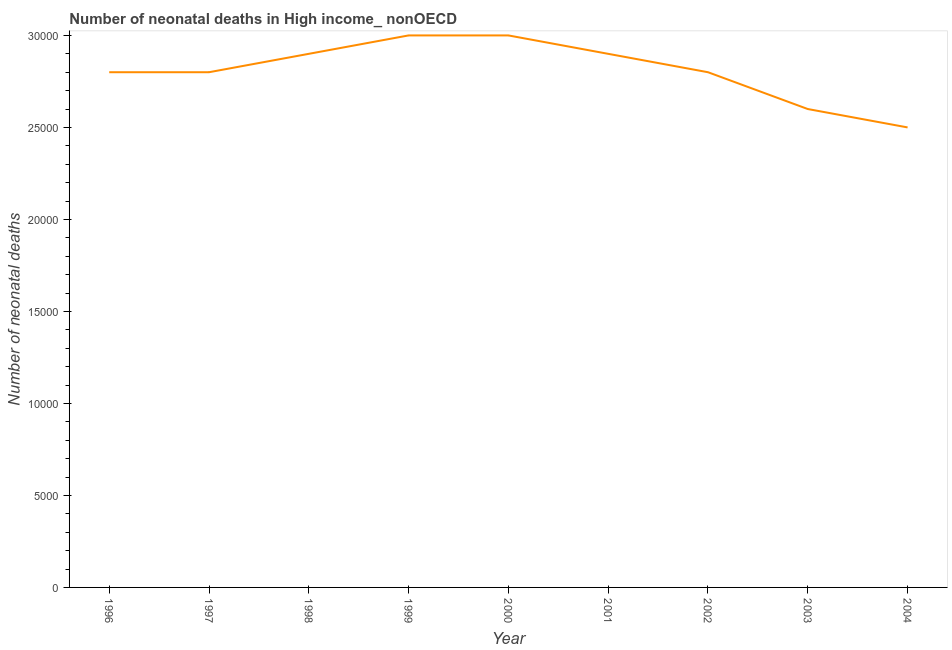What is the number of neonatal deaths in 1996?
Keep it short and to the point. 2.80e+04. Across all years, what is the maximum number of neonatal deaths?
Make the answer very short. 3.00e+04. Across all years, what is the minimum number of neonatal deaths?
Your answer should be very brief. 2.50e+04. What is the sum of the number of neonatal deaths?
Ensure brevity in your answer.  2.53e+05. What is the difference between the number of neonatal deaths in 1997 and 1998?
Provide a succinct answer. -1000. What is the average number of neonatal deaths per year?
Your answer should be compact. 2.81e+04. What is the median number of neonatal deaths?
Give a very brief answer. 2.80e+04. What is the ratio of the number of neonatal deaths in 1997 to that in 2003?
Your answer should be very brief. 1.08. What is the difference between the highest and the lowest number of neonatal deaths?
Your answer should be very brief. 5000. In how many years, is the number of neonatal deaths greater than the average number of neonatal deaths taken over all years?
Give a very brief answer. 4. Does the number of neonatal deaths monotonically increase over the years?
Give a very brief answer. No. How many years are there in the graph?
Offer a terse response. 9. Are the values on the major ticks of Y-axis written in scientific E-notation?
Your answer should be very brief. No. What is the title of the graph?
Provide a short and direct response. Number of neonatal deaths in High income_ nonOECD. What is the label or title of the X-axis?
Make the answer very short. Year. What is the label or title of the Y-axis?
Make the answer very short. Number of neonatal deaths. What is the Number of neonatal deaths in 1996?
Give a very brief answer. 2.80e+04. What is the Number of neonatal deaths of 1997?
Your answer should be compact. 2.80e+04. What is the Number of neonatal deaths of 1998?
Keep it short and to the point. 2.90e+04. What is the Number of neonatal deaths in 2000?
Offer a terse response. 3.00e+04. What is the Number of neonatal deaths in 2001?
Provide a succinct answer. 2.90e+04. What is the Number of neonatal deaths of 2002?
Make the answer very short. 2.80e+04. What is the Number of neonatal deaths of 2003?
Offer a terse response. 2.60e+04. What is the Number of neonatal deaths in 2004?
Your answer should be compact. 2.50e+04. What is the difference between the Number of neonatal deaths in 1996 and 1998?
Your response must be concise. -1000. What is the difference between the Number of neonatal deaths in 1996 and 1999?
Ensure brevity in your answer.  -2000. What is the difference between the Number of neonatal deaths in 1996 and 2000?
Your response must be concise. -2000. What is the difference between the Number of neonatal deaths in 1996 and 2001?
Provide a short and direct response. -1000. What is the difference between the Number of neonatal deaths in 1996 and 2004?
Your response must be concise. 3000. What is the difference between the Number of neonatal deaths in 1997 and 1998?
Offer a terse response. -1000. What is the difference between the Number of neonatal deaths in 1997 and 1999?
Offer a very short reply. -2000. What is the difference between the Number of neonatal deaths in 1997 and 2000?
Your answer should be compact. -2000. What is the difference between the Number of neonatal deaths in 1997 and 2001?
Your answer should be compact. -1000. What is the difference between the Number of neonatal deaths in 1997 and 2003?
Give a very brief answer. 2000. What is the difference between the Number of neonatal deaths in 1997 and 2004?
Provide a succinct answer. 3000. What is the difference between the Number of neonatal deaths in 1998 and 1999?
Offer a very short reply. -1000. What is the difference between the Number of neonatal deaths in 1998 and 2000?
Your answer should be very brief. -1000. What is the difference between the Number of neonatal deaths in 1998 and 2001?
Keep it short and to the point. 0. What is the difference between the Number of neonatal deaths in 1998 and 2003?
Your response must be concise. 3000. What is the difference between the Number of neonatal deaths in 1998 and 2004?
Provide a short and direct response. 4000. What is the difference between the Number of neonatal deaths in 1999 and 2001?
Make the answer very short. 1000. What is the difference between the Number of neonatal deaths in 1999 and 2003?
Give a very brief answer. 4000. What is the difference between the Number of neonatal deaths in 1999 and 2004?
Keep it short and to the point. 5000. What is the difference between the Number of neonatal deaths in 2000 and 2002?
Ensure brevity in your answer.  2000. What is the difference between the Number of neonatal deaths in 2000 and 2003?
Your response must be concise. 4000. What is the difference between the Number of neonatal deaths in 2000 and 2004?
Provide a succinct answer. 5000. What is the difference between the Number of neonatal deaths in 2001 and 2003?
Make the answer very short. 3000. What is the difference between the Number of neonatal deaths in 2001 and 2004?
Offer a very short reply. 4000. What is the difference between the Number of neonatal deaths in 2002 and 2003?
Make the answer very short. 2000. What is the difference between the Number of neonatal deaths in 2002 and 2004?
Offer a terse response. 3000. What is the ratio of the Number of neonatal deaths in 1996 to that in 1999?
Your answer should be very brief. 0.93. What is the ratio of the Number of neonatal deaths in 1996 to that in 2000?
Your answer should be very brief. 0.93. What is the ratio of the Number of neonatal deaths in 1996 to that in 2003?
Ensure brevity in your answer.  1.08. What is the ratio of the Number of neonatal deaths in 1996 to that in 2004?
Your answer should be very brief. 1.12. What is the ratio of the Number of neonatal deaths in 1997 to that in 1999?
Your answer should be compact. 0.93. What is the ratio of the Number of neonatal deaths in 1997 to that in 2000?
Ensure brevity in your answer.  0.93. What is the ratio of the Number of neonatal deaths in 1997 to that in 2002?
Your response must be concise. 1. What is the ratio of the Number of neonatal deaths in 1997 to that in 2003?
Ensure brevity in your answer.  1.08. What is the ratio of the Number of neonatal deaths in 1997 to that in 2004?
Offer a terse response. 1.12. What is the ratio of the Number of neonatal deaths in 1998 to that in 1999?
Your response must be concise. 0.97. What is the ratio of the Number of neonatal deaths in 1998 to that in 2001?
Your answer should be compact. 1. What is the ratio of the Number of neonatal deaths in 1998 to that in 2002?
Provide a short and direct response. 1.04. What is the ratio of the Number of neonatal deaths in 1998 to that in 2003?
Your answer should be compact. 1.11. What is the ratio of the Number of neonatal deaths in 1998 to that in 2004?
Provide a succinct answer. 1.16. What is the ratio of the Number of neonatal deaths in 1999 to that in 2000?
Your response must be concise. 1. What is the ratio of the Number of neonatal deaths in 1999 to that in 2001?
Your answer should be compact. 1.03. What is the ratio of the Number of neonatal deaths in 1999 to that in 2002?
Your response must be concise. 1.07. What is the ratio of the Number of neonatal deaths in 1999 to that in 2003?
Provide a short and direct response. 1.15. What is the ratio of the Number of neonatal deaths in 1999 to that in 2004?
Offer a terse response. 1.2. What is the ratio of the Number of neonatal deaths in 2000 to that in 2001?
Make the answer very short. 1.03. What is the ratio of the Number of neonatal deaths in 2000 to that in 2002?
Your answer should be very brief. 1.07. What is the ratio of the Number of neonatal deaths in 2000 to that in 2003?
Your answer should be compact. 1.15. What is the ratio of the Number of neonatal deaths in 2001 to that in 2002?
Offer a very short reply. 1.04. What is the ratio of the Number of neonatal deaths in 2001 to that in 2003?
Make the answer very short. 1.11. What is the ratio of the Number of neonatal deaths in 2001 to that in 2004?
Make the answer very short. 1.16. What is the ratio of the Number of neonatal deaths in 2002 to that in 2003?
Provide a short and direct response. 1.08. What is the ratio of the Number of neonatal deaths in 2002 to that in 2004?
Provide a succinct answer. 1.12. What is the ratio of the Number of neonatal deaths in 2003 to that in 2004?
Offer a terse response. 1.04. 